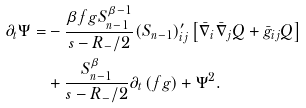<formula> <loc_0><loc_0><loc_500><loc_500>\partial _ { t } \Psi = & - \frac { \beta f g S _ { n - 1 } ^ { \beta - 1 } } { s - R _ { - } / 2 } ( S _ { n - 1 } ) ^ { \prime } _ { i j } \left [ \bar { \nabla } _ { i } \bar { \nabla } _ { j } Q + \bar { g } _ { i j } Q \right ] \\ & + \frac { S _ { n - 1 } ^ { \beta } } { s - R _ { - } / 2 } \partial _ { t } \left ( f g \right ) + \Psi ^ { 2 } .</formula> 